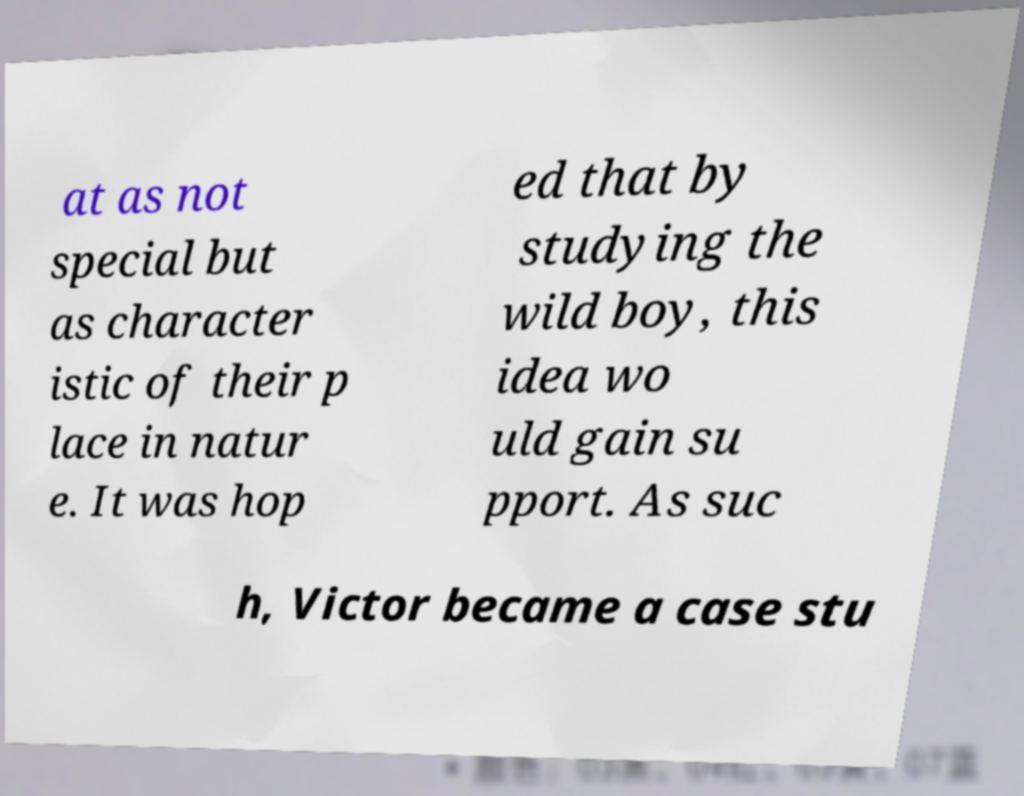What messages or text are displayed in this image? I need them in a readable, typed format. at as not special but as character istic of their p lace in natur e. It was hop ed that by studying the wild boy, this idea wo uld gain su pport. As suc h, Victor became a case stu 